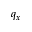<formula> <loc_0><loc_0><loc_500><loc_500>q _ { x }</formula> 